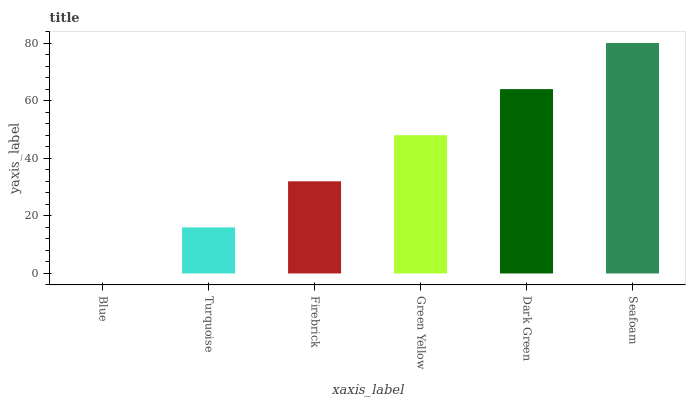Is Turquoise the minimum?
Answer yes or no. No. Is Turquoise the maximum?
Answer yes or no. No. Is Turquoise greater than Blue?
Answer yes or no. Yes. Is Blue less than Turquoise?
Answer yes or no. Yes. Is Blue greater than Turquoise?
Answer yes or no. No. Is Turquoise less than Blue?
Answer yes or no. No. Is Green Yellow the high median?
Answer yes or no. Yes. Is Firebrick the low median?
Answer yes or no. Yes. Is Blue the high median?
Answer yes or no. No. Is Blue the low median?
Answer yes or no. No. 